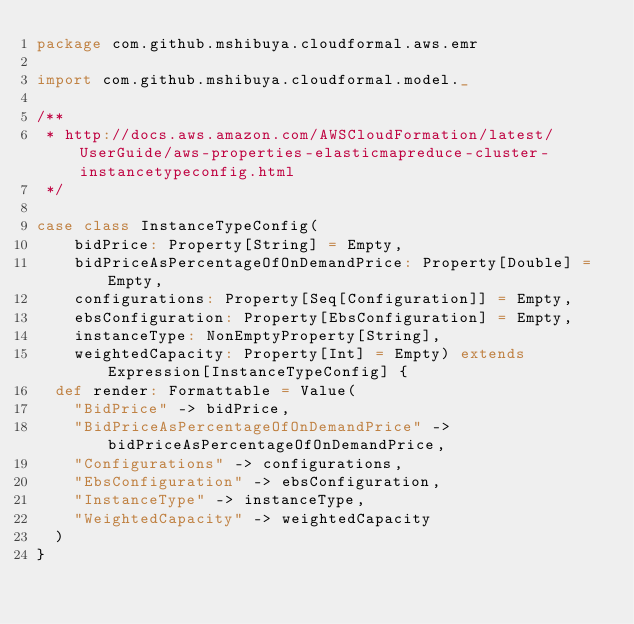<code> <loc_0><loc_0><loc_500><loc_500><_Scala_>package com.github.mshibuya.cloudformal.aws.emr

import com.github.mshibuya.cloudformal.model._

/**
 * http://docs.aws.amazon.com/AWSCloudFormation/latest/UserGuide/aws-properties-elasticmapreduce-cluster-instancetypeconfig.html
 */

case class InstanceTypeConfig(
    bidPrice: Property[String] = Empty,
    bidPriceAsPercentageOfOnDemandPrice: Property[Double] = Empty,
    configurations: Property[Seq[Configuration]] = Empty,
    ebsConfiguration: Property[EbsConfiguration] = Empty,
    instanceType: NonEmptyProperty[String],
    weightedCapacity: Property[Int] = Empty) extends Expression[InstanceTypeConfig] {
  def render: Formattable = Value(
    "BidPrice" -> bidPrice,
    "BidPriceAsPercentageOfOnDemandPrice" -> bidPriceAsPercentageOfOnDemandPrice,
    "Configurations" -> configurations,
    "EbsConfiguration" -> ebsConfiguration,
    "InstanceType" -> instanceType,
    "WeightedCapacity" -> weightedCapacity
  )
}
</code> 